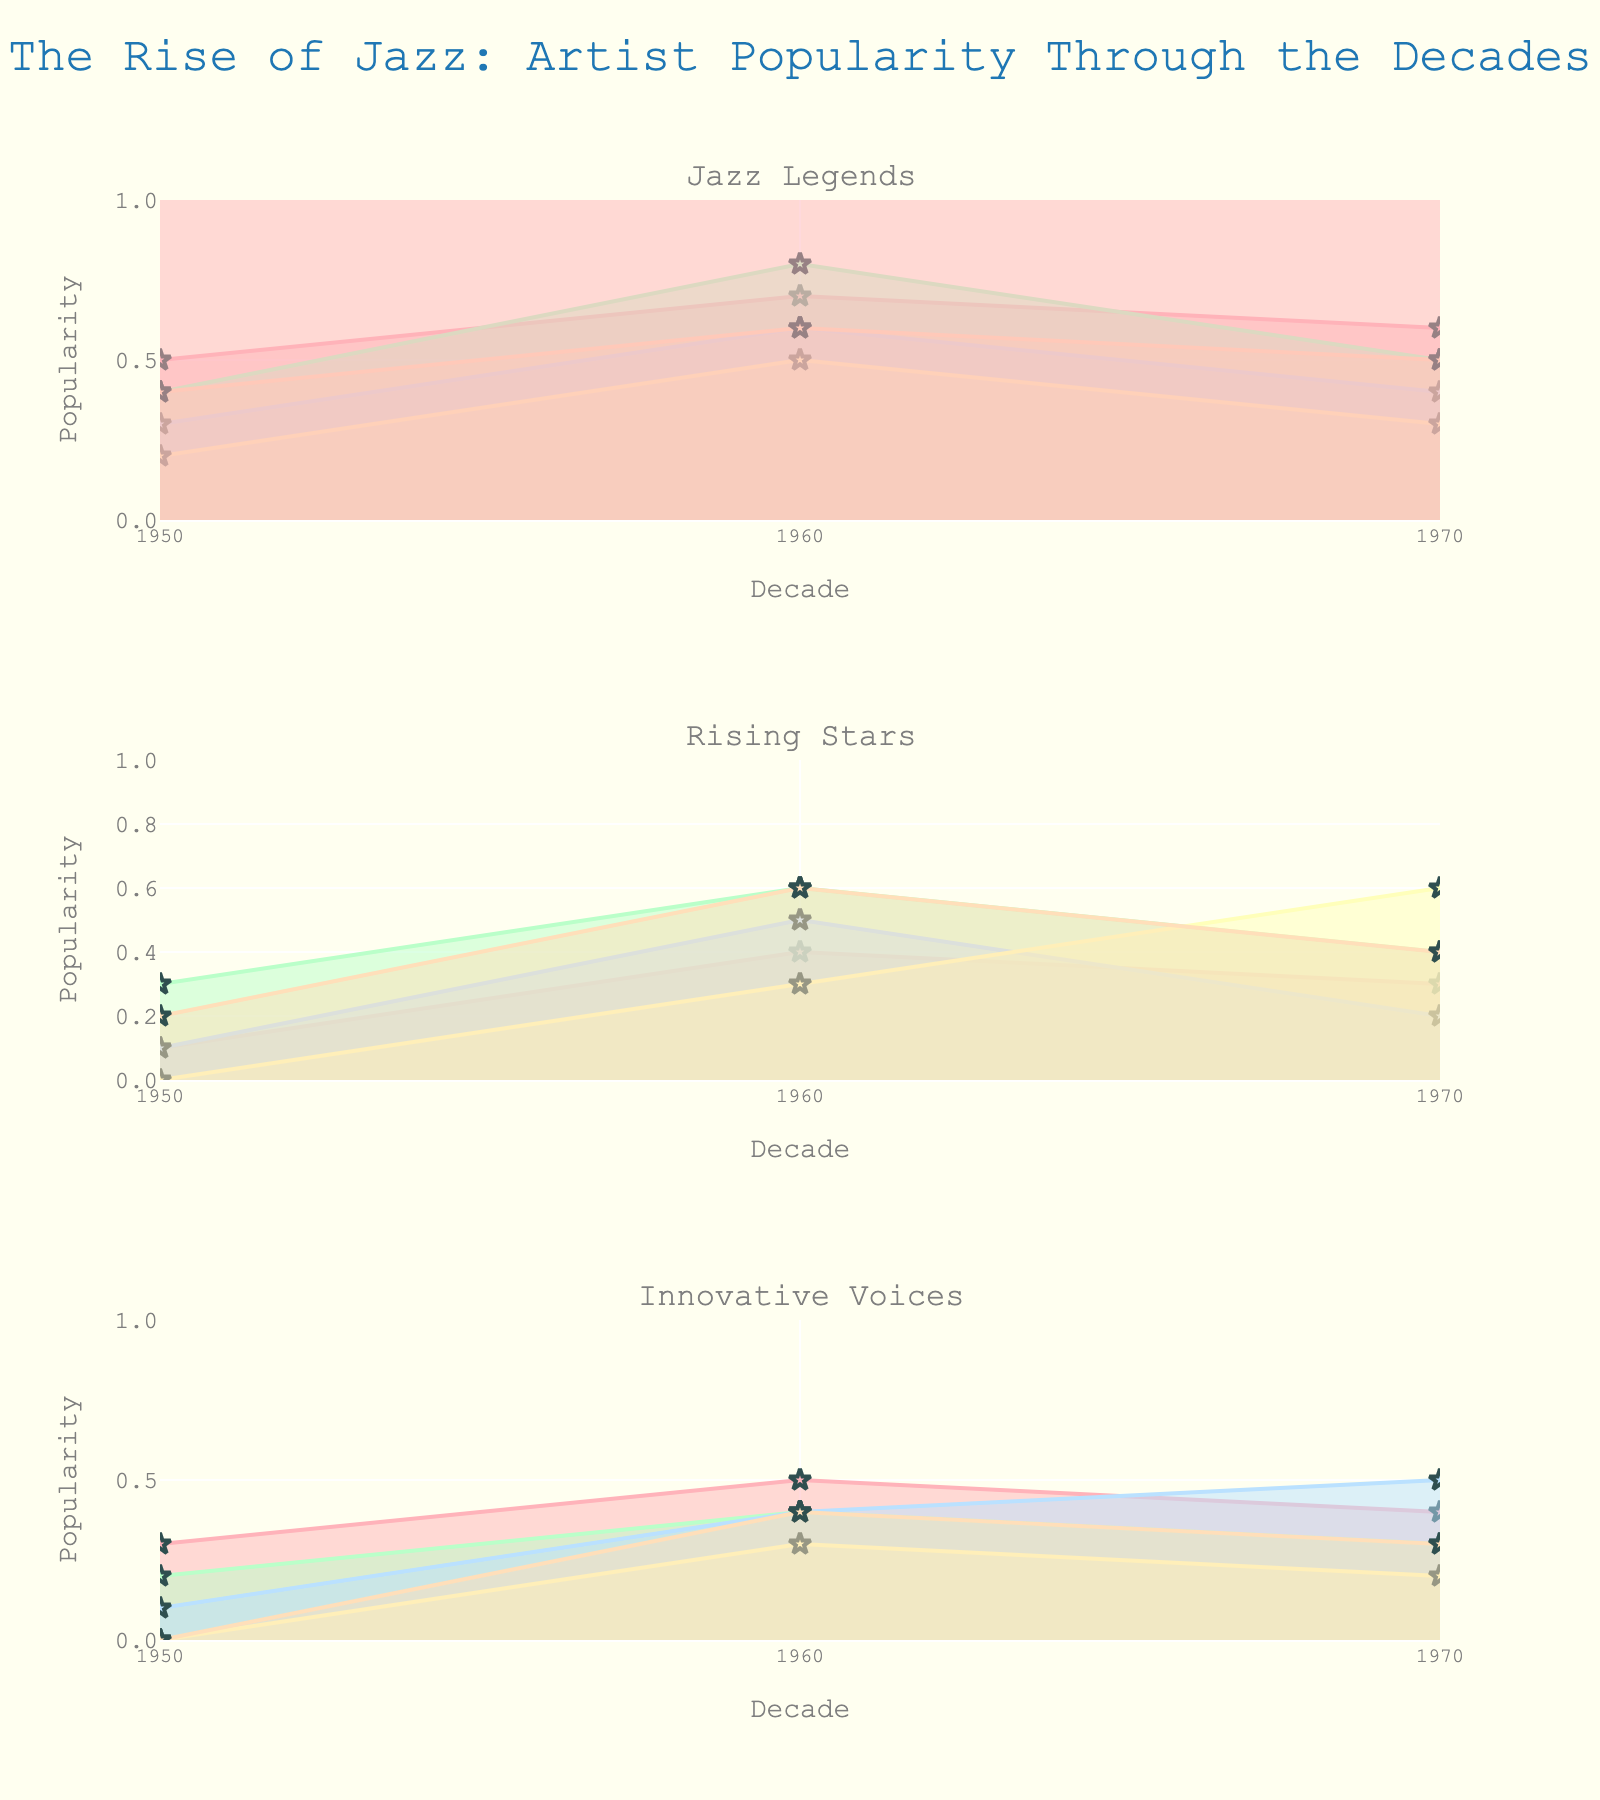Which decade is displayed on the x-axis? The x-axis of each subplot displays the decades 1950, 1960, and 1970, as per the data columns specified.
Answer: 1950, 1960, 1970 Which artist shows a peak popularity in the 1960s in the 'Jazz Legends' subplot? Looking at the 'Jazz Legends' subplot, John Coltrane reaches a peak popularity score of 0.8 in the 1960s.
Answer: John Coltrane How does Bill Evans' popularity change from the 1950s to the 1970s? Bill Evans' popularity increases from 0.2 in the 1950s to 0.6 in the 1960s and then decreases to 0.4 in the 1970s.
Answer: Increases, then decreases Which artist's popularity has the most dramatic increase from the 1950s to the 1960s in the 'Rising Stars' subplot? In the 'Rising Stars' subplot, Cannonball Adderley's popularity increased from 0.1 to 0.4 from the 1950s to the 1960s, showing the most dramatic increase.
Answer: Cannonball Adderley Compare the popularity of Miles Davis and Thelonious Monk in the 1960s. Who was more popular? In the 1960s, Miles Davis had a popularity score of 0.7, while Thelonious Monk had 0.6. Thus, Miles Davis was more popular.
Answer: Miles Davis What is the average popularity of Ornette Coleman across the three decades? The average popularity of Ornette Coleman can be calculated by (0.1 + 0.5 + 0.2)/3 = 0.2667.
Answer: 0.2667 (approx 0.27) Which subplot features more artists, 'Rising Stars' or 'Innovative Voices'? Both the 'Rising Stars' and 'Innovative Voices' subplots feature 5 artists each.
Answer: Equal (5 artists each) Which artist has a continuous increase in popularity from 1950 to 1970? Herbie Hancock's popularity shows a continuous increase from 0.0 in the 1950s to 0.3 in the 1960s and 0.6 in the 1970s.
Answer: Herbie Hancock Who among 'Innovative Voices' shows a peak popularity in the 1960s and then declines in the 1970s? Art Blakey's popularity peaks at 0.5 in the 1960s and then declines to 0.4 in the 1970s.
Answer: Art Blakey 